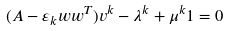<formula> <loc_0><loc_0><loc_500><loc_500>( A - \varepsilon _ { k } w w ^ { T } ) v ^ { k } - \lambda ^ { k } + \mu ^ { k } { 1 } = 0</formula> 